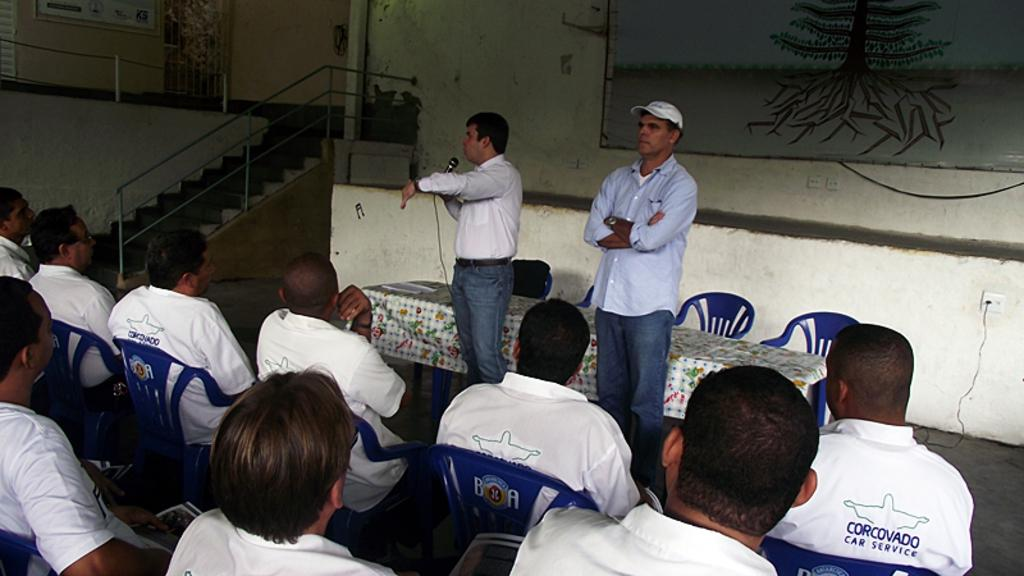Provide a one-sentence caption for the provided image. The group of people who are sitting down are wearing shirts that say Corcovado Car Service. 